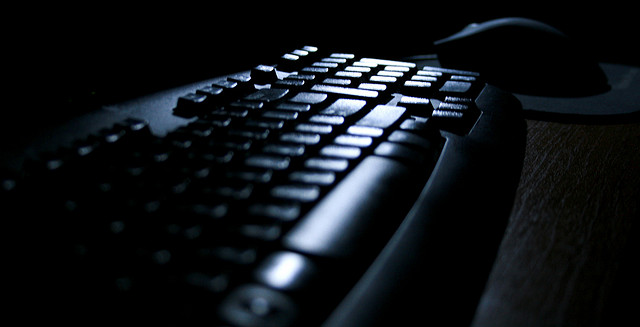<image>What brand of computer is this? I don't know the exact brand of the computer. It can be Dell or HP. What brand of computer is this? This computer is of the Dell brand. 